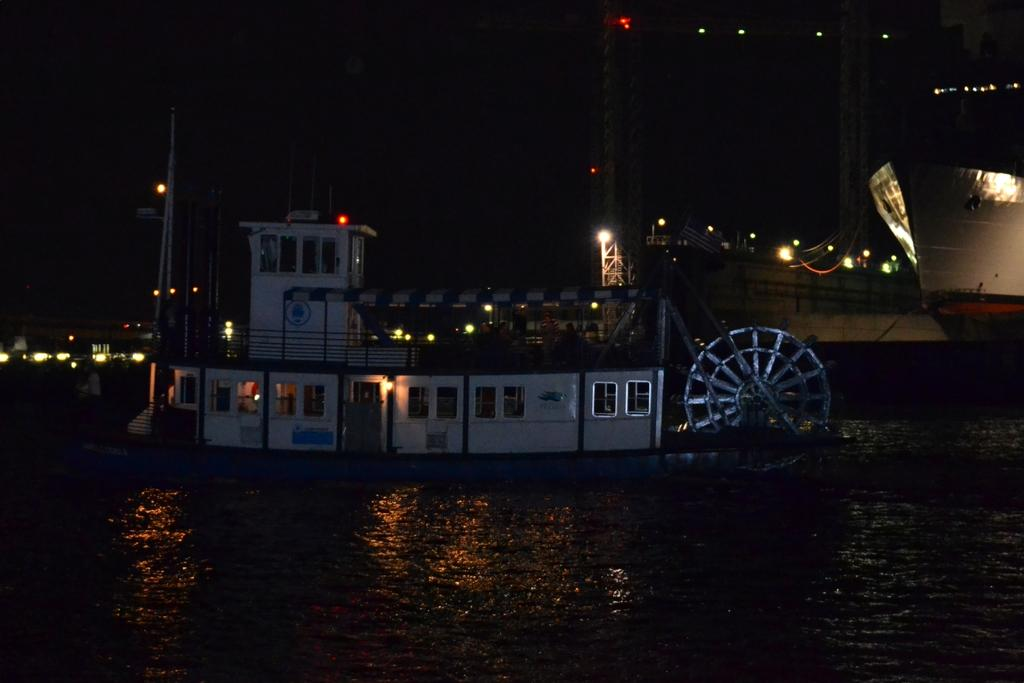What is in the water in the image? There is a boat in the water in the image. What else can be seen in the water besides the boat? There are many ships behind the boat in the water. Can you describe any other features of the image? There are lights visible in the image. What type of cough can be heard coming from the boat in the image? There is no sound, including coughing, present in the image. How does the boat expand in the image? The boat does not expand in the image; it is a static representation. 